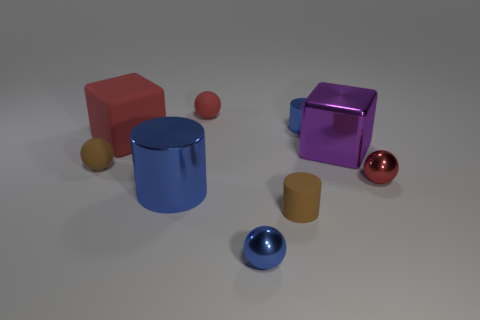Is the size of the shiny ball in front of the small brown rubber cylinder the same as the red matte block that is behind the big purple cube?
Your response must be concise. No. Is the size of the brown matte ball the same as the metal object that is behind the purple metal object?
Ensure brevity in your answer.  Yes. The purple block has what size?
Your answer should be very brief. Large. The small cylinder that is made of the same material as the big red block is what color?
Keep it short and to the point. Brown. What number of blue things have the same material as the small blue ball?
Provide a succinct answer. 2. How many objects are either tiny matte spheres or tiny things that are behind the purple metal object?
Make the answer very short. 3. Are the small red sphere behind the purple metal thing and the large red block made of the same material?
Provide a succinct answer. Yes. What is the color of the metallic cylinder that is the same size as the brown rubber ball?
Make the answer very short. Blue. Is there a large blue object of the same shape as the small red matte object?
Give a very brief answer. No. What color is the tiny rubber thing that is in front of the small brown rubber thing that is to the left of the small rubber ball that is right of the big red matte thing?
Provide a short and direct response. Brown. 